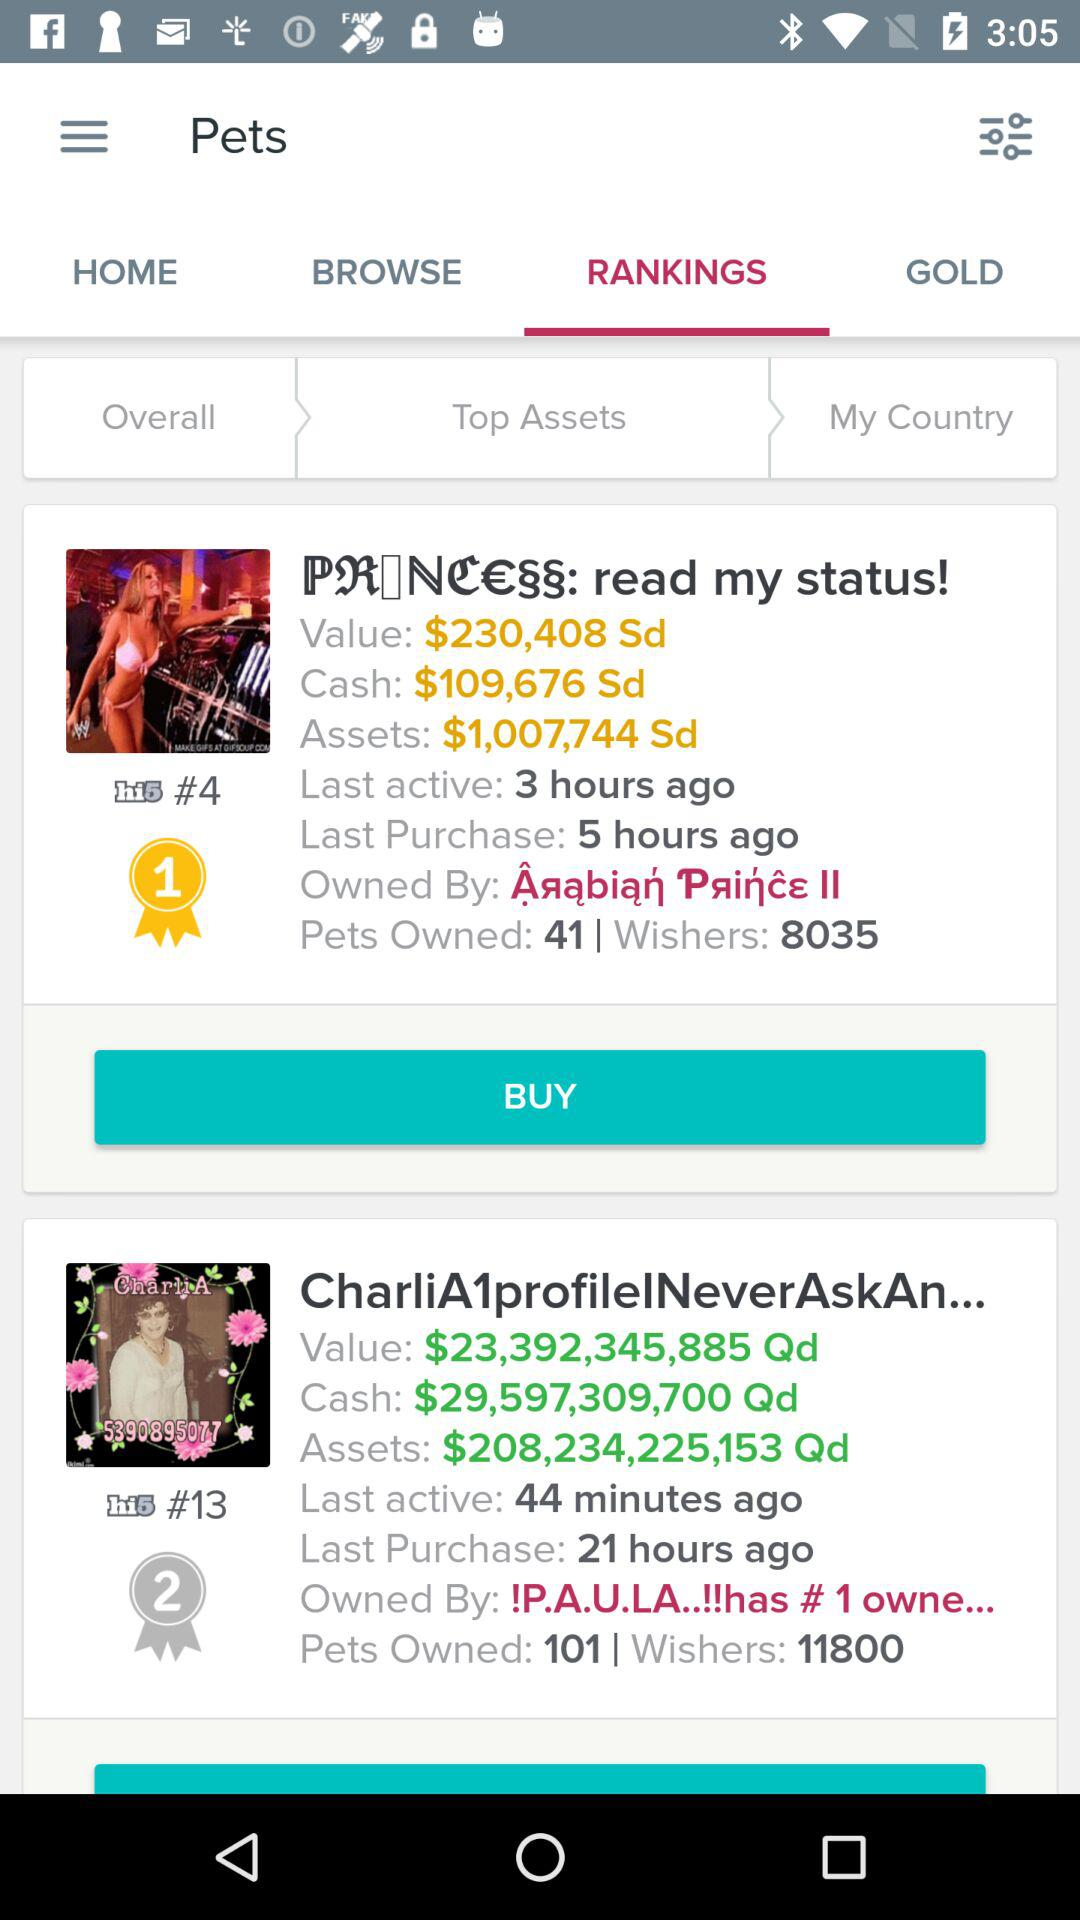Which pet has more pets owned, PRANCESS or CharliA1profileNeverAskAn?
Answer the question using a single word or phrase. CharliA1profileNeverAskAn 